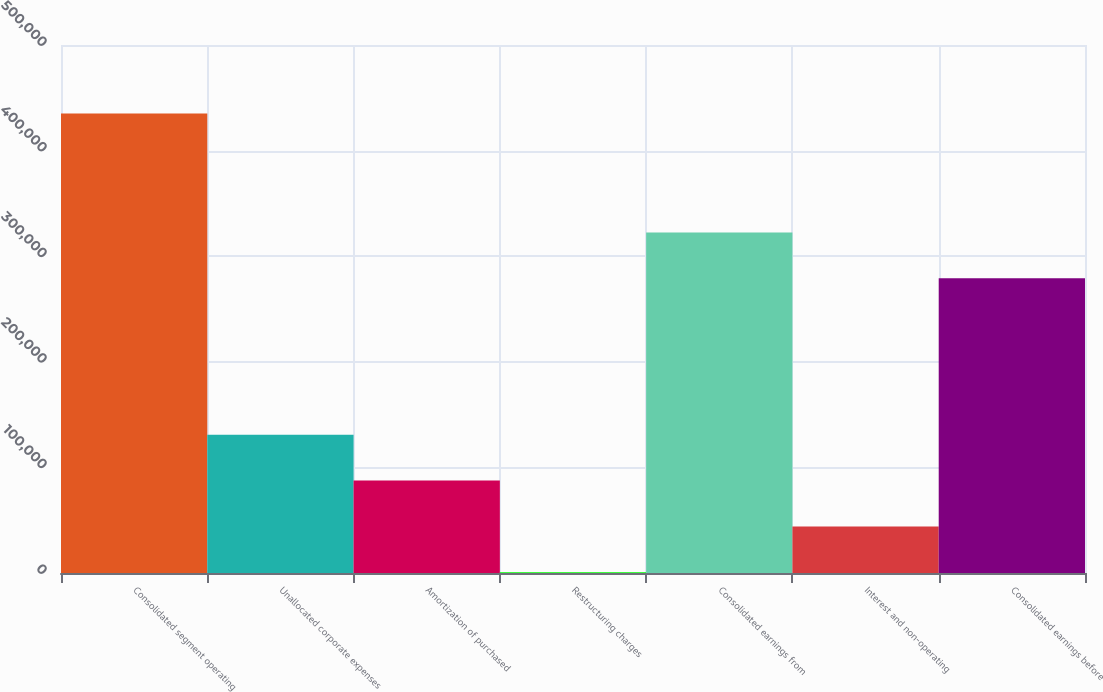Convert chart to OTSL. <chart><loc_0><loc_0><loc_500><loc_500><bar_chart><fcel>Consolidated segment operating<fcel>Unallocated corporate expenses<fcel>Amortization of purchased<fcel>Restructuring charges<fcel>Consolidated earnings from<fcel>Interest and non-operating<fcel>Consolidated earnings before<nl><fcel>435129<fcel>130976<fcel>87525.8<fcel>625<fcel>322515<fcel>44075.4<fcel>279065<nl></chart> 